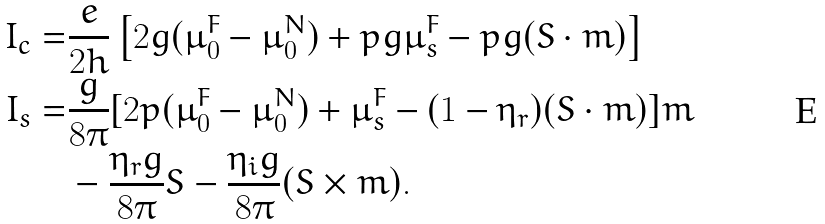Convert formula to latex. <formula><loc_0><loc_0><loc_500><loc_500>I _ { c } = & \frac { e } { 2 h } \left [ 2 g ( \mu _ { 0 } ^ { F } - \mu _ { 0 } ^ { N } ) + p g \mu _ { s } ^ { F } - p g ( S \cdot m ) \right ] \\ I _ { s } = & \frac { g } { 8 \pi } [ 2 p ( \mu _ { 0 } ^ { F } - \mu _ { 0 } ^ { N } ) + \mu _ { s } ^ { F } - ( 1 - \eta _ { r } ) ( S \cdot m ) ] m \\ & - \frac { \eta _ { r } g } { 8 \pi } S - \frac { \eta _ { i } g } { 8 \pi } ( S \times m ) .</formula> 